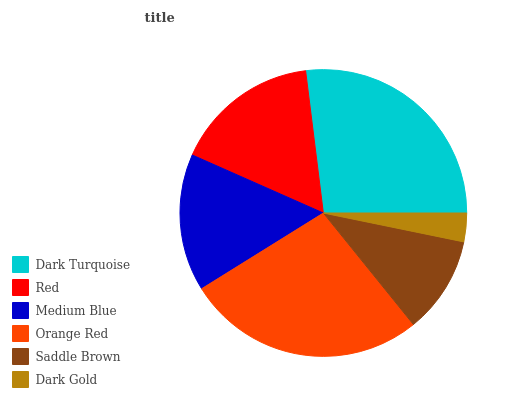Is Dark Gold the minimum?
Answer yes or no. Yes. Is Dark Turquoise the maximum?
Answer yes or no. Yes. Is Red the minimum?
Answer yes or no. No. Is Red the maximum?
Answer yes or no. No. Is Dark Turquoise greater than Red?
Answer yes or no. Yes. Is Red less than Dark Turquoise?
Answer yes or no. Yes. Is Red greater than Dark Turquoise?
Answer yes or no. No. Is Dark Turquoise less than Red?
Answer yes or no. No. Is Red the high median?
Answer yes or no. Yes. Is Medium Blue the low median?
Answer yes or no. Yes. Is Dark Gold the high median?
Answer yes or no. No. Is Dark Gold the low median?
Answer yes or no. No. 